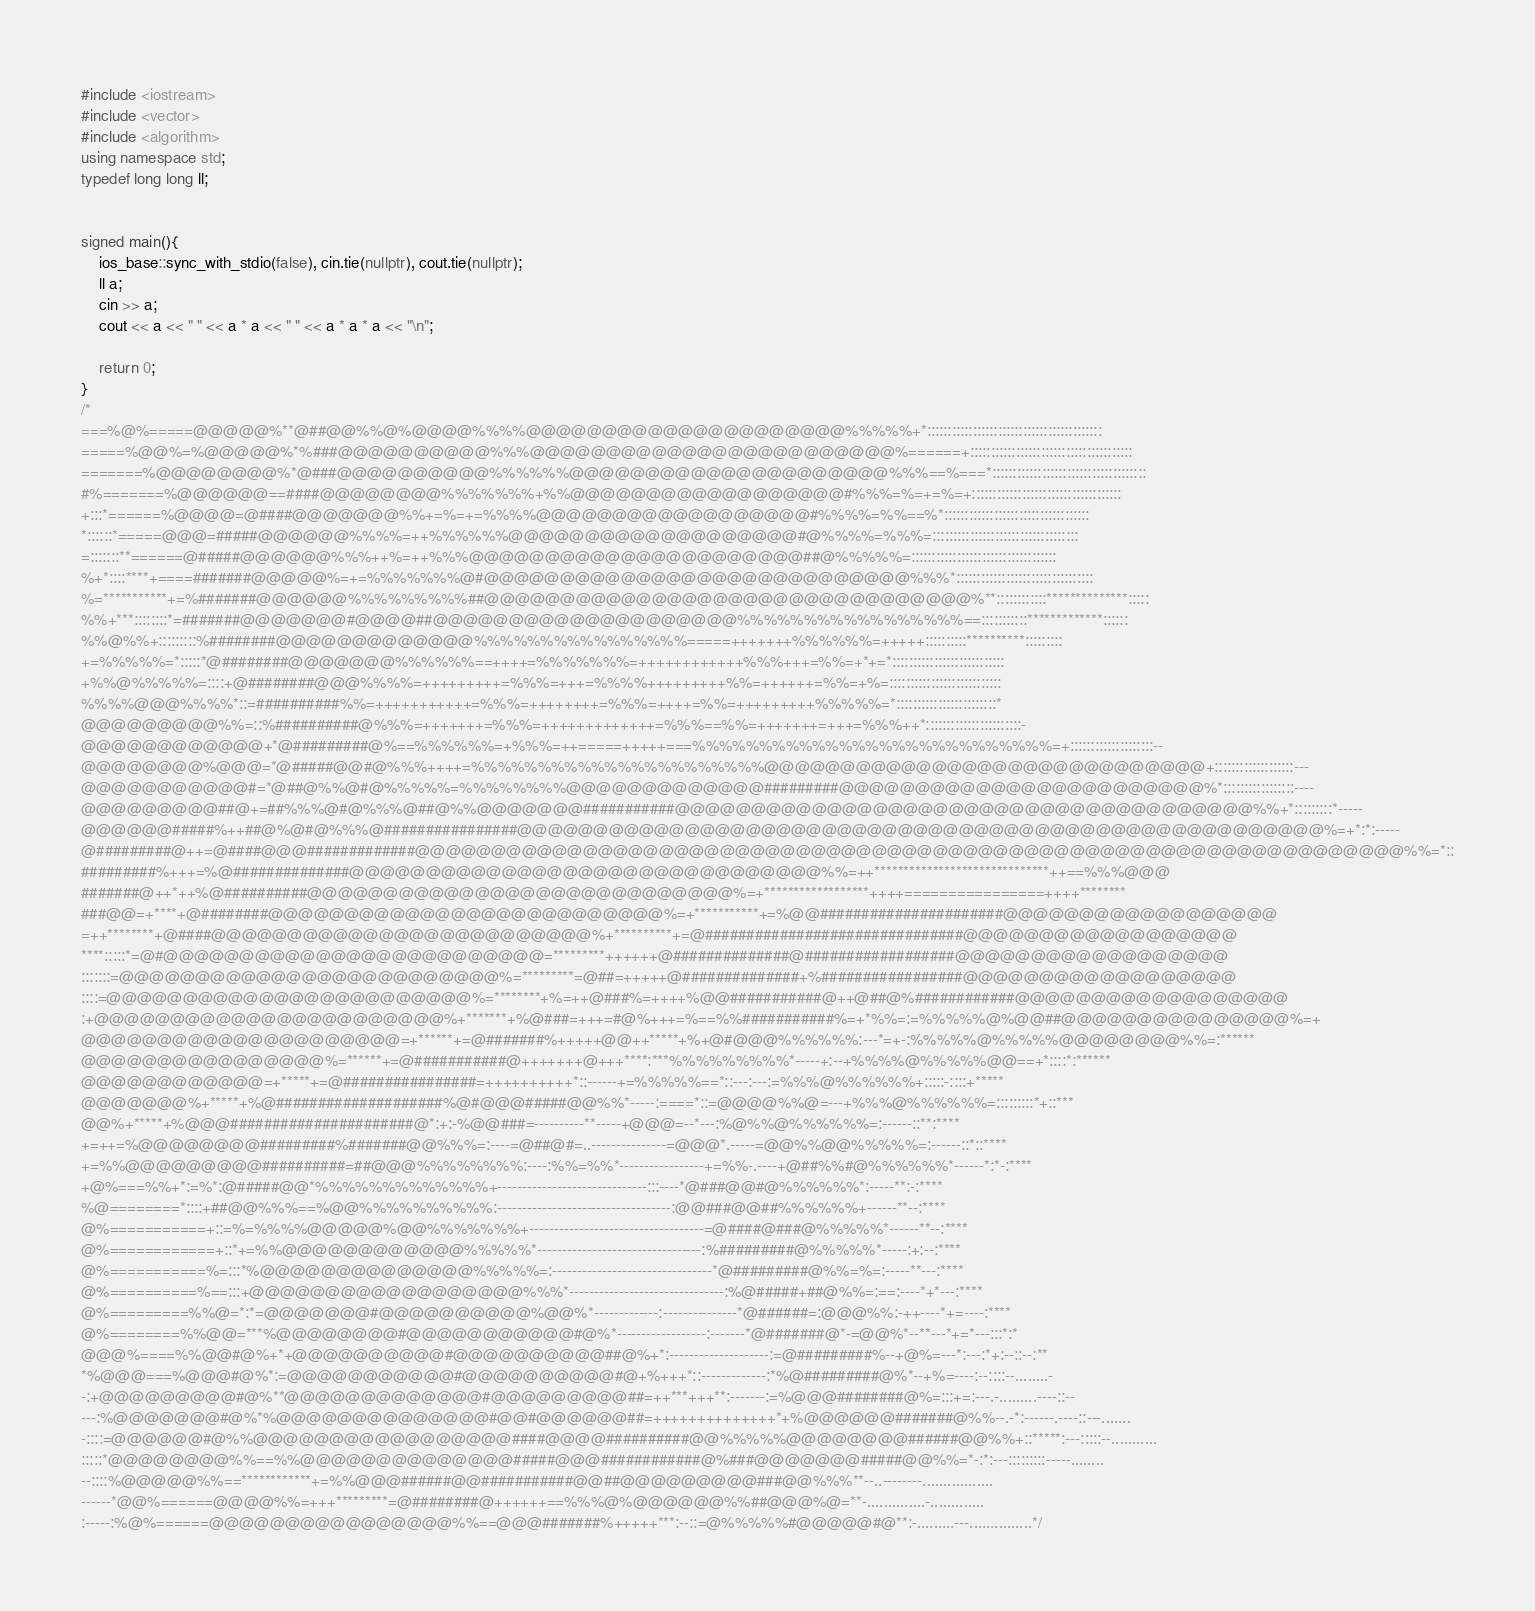<code> <loc_0><loc_0><loc_500><loc_500><_C++_>#include <iostream>
#include <vector>
#include <algorithm>
using namespace std;
typedef long long ll;


signed main(){
    ios_base::sync_with_stdio(false), cin.tie(nullptr), cout.tie(nullptr);
    ll a;
    cin >> a;
    cout << a << " " << a * a << " " << a * a * a << "\n";

    return 0;
}
/*
===%@%=====@@@@@%**@##@@%%@%@@@@%%%%@@@@@@@@@@@@@@@@@@@@@%%%%%+*::::::::::::::::::::::::::::::::::::::::::
=====%@@%=%@@@@@%*%###@@@@@@@@@@%%%@@@@@@@@@@@@@@@@@@@@@@@@%======+:::::::::::::::::::::::::::::::::::::::
=======%@@@@@@@@%*@###@@@@@@@@@@%%%%%%@@@@@@@@@@@@@@@@@@@@@%%%==%===*:::::::::::::::::::::::::::::::::::::
#%=======%@@@@@@==####@@@@@@@@%%%%%%%+%%@@@@@@@@@@@@@@@@@@#%%%=%=+=%=+::::::::::::::::::::::::::::::::::::
+:::*======%@@@@=@####@@@@@@@%%+=%=+=%%%%@@@@@@@@@@@@@@@@@@#%%%%=%%==%*:::::::::::::::::::::::::::::::::::
*::::::*=====@@@=#####@@@@@@%%%%=++%%%%%%@@@@@@@@@@@@@@@@@@@#@%%%%=%%%=:::::::::::::::::::::::::::::::::::
=:::::::**======@#####@@@@@@%%%++%=++%%%@@@@@@@@@@@@@@@@@@@@@@##@%%%%%=:::::::::::::::::::::::::::::::::::
%+*::::****+====#######@@@@@%=+=%%%%%%%@#@@@@@@@@@@@@@@@@@@@@@@@@@@@@%%%*:::::::::::::::::::::::::::::::::
%=***********+=%#######@@@@@@%%%%%%%%%##@@@@@@@@@@@@@@@@@@@@@@@@@@@@@@@@%**::::::::::::**************:::::
%%+***::::::::*=#######@@@@@@@#@@@@##@@@@@@@@@@@@@@@@@@@@%%%%%%%%%%%%%%%%%==:::::::::::*************::::::
%%@%%+:::::::::%########@@@@@@@@@@@@@%%%%%%%%%%%%%%%%=====+++++++%%%%%%=+++++::::::::::**********:::::::::
+=%%%%%=*:::::*@########@@@@@@@%%%%%%==++++=%%%%%%%=++++++++++++%%%+++=%%=+*+=*:::::::::::::::::::::::::::
+%%@%%%%%=::::+@########@@@%%%%=+++++++++=%%%=+++=%%%%+++++++++%%=++++++=%%=+%=:::::::::::::::::::::::::::
%%%%@@@%%%%*::=##########%%=+++++++++++=%%%=++++++++=%%%=++++=%%=+++++++++%%%%%=*::::::::::::::::::::::::*
@@@@@@@@@%%=::%##########@%%%=+++++++=%%%=+++++++++++++=%%%==%%=+++++++=+++=%%%++*:::::::::::::::::::::::-
@@@@@@@@@@@@+*@#########@%==%%%%%%=+%%%=++=====+++++===%%%%%%%%%%%%%%%%%%%%%%%%%%%=+::::::::::::::::::::--
@@@@@@@@%@@@=*@#####@@#@%%%++++=%%%%%%%%%%%%%%%%%%%%%%@@@@@@@@@@@@@@@@@@@@@@@@@@@@@+:::::::::::::::::::---
@@@@@@@@@@@#=*@##@%%@#@%%%%%=%%%%%%%%@@@@@@@@@@@@@#########@@@@@@@@@@@@@@@@@@@@@@@@%*:::::::::::::::::----
@@@@@@@@@##@+=##%%%@#@%%%@##@%%@@@@@@@###########@@@@@@@@@@@@@@@@@@@@@@@@@@@@@@@@@@@@@@%%+*:::::::::*-----
@@@@@@#####%++##@%@#@%%%@################@@@@@@@@@@@@@@@@@@@@@@@@@@@@@@@@@@@@@@@@@@@@@@@@@@@@@%=+*:*:-----
@#########@++=@####@@@#############@@@@@@@@@@@@@@@@@@@@@@@@@@@@@@@@@@@@@@@@@@@@@@@@@@@@@@@@@@@@@@@@@%%=*::
#########%+++=%@##############@@@@@@@@@@@@@@@@@@@@@@@@@@@@@@@%%=++******************************++==%%%@@@
#######@++*++%@##########@@@@@@@@@@@@@@@@@@@@@@@@@@@@%=+******************++++================++++********
###@@=+****+@########@@@@@@@@@@@@@@@@@@@@@@@@@@%=+***********+=%@@######################@@@@@@@@@@@@@@@@@@
=++********+@####@@@@@@@@@@@@@@@@@@@@@@@@@%+**********+=@###############################@@@@@@@@@@@@@@@@@@
****:::::*=@#@@@@@@@@@@@@@@@@@@@@@@@@@=*********++++++@##############@##################@@@@@@@@@@@@@@@@@@
:::::::=@@@@@@@@@@@@@@@@@@@@@@@@@%=*********=@##=+++++@##############+%#################@@@@@@@@@@@@@@@@@@
::::=@@@@@@@@@@@@@@@@@@@@@@@@%=********+%=++@###%=++++%@@###########@++@##@%############@@@@@@@@@@@@@@@@@@
:+@@@@@@@@@@@@@@@@@@@@@@@%+*******+%@###=+++=#@%+++=%==%%###########%=+*%%=:=%%%%%@%@@##@@@@@@@@@@@@@@@%=+
@@@@@@@@@@@@@@@@@@@@@=+******+=@#######%+++++@@++*****+%+@#@@@%%%%%%:---*=+-:%%%%%@%%%%%@@@@@@@@%%=:******
@@@@@@@@@@@@@@@@%=******+=@###########@+++++++@+++****:***%%%%%%%%%*-----+:--+%%%%@%%%%%@@==+*::::*:******
@@@@@@@@@@@@=+*****+=@################=++++++++++*::------+=%%%%%==*::---:---:=%%%@%%%%%%+:::::-::::+*****
@@@@@@@%+*****+%@####################%@#@@@#####@@%%*-----:====*::=@@@@%%@=---+%%%@%%%%%%=:::::::::*+::***
@@%+*****+%@@@######################@*:+:-%@@###=----------**-----+@@@=--*---:%@%%@%%%%%%=:------::**:****
+=++=%@@@@@@@@#########%#######@@%%%=:----=@##@#=..---------------=@@@*.-----=@@%%@@%%%%%=:------::*::****
+=%%@@@@@@@@@##########=##@@@%%%%%%%%:----:%%=%%*-----------------+=%%-.----+@##%%#@%%%%%%*------*:*-:****
+@%===%%+*:=%*:@#####@@*%%%%%%%%%%%%%+------------------------------:::----*@###@@#@%%%%%%*:-----**:-:****
%@========*::::+##@@%%%==%@@%%%%%%%%%%:-----------------------------------:@@###@@##%%%%%%+------**--:****
@%===========+::=%=%%%%@@@@@%@@%%%%%%%+-----------------------------------=@####@###@%%%%%*------**--:****
@%============+::*+=%%@@@@@@@@@@@@%%%%%*---------------------------------:%#########@%%%%%*-----:+:--:****
@%===========%=:::*%@@@@@@@@@@@@@@%%%%%=:--------------------------------*@#########@%%=%=:-----**---:****
@%==========%==:::+@@@@@@@@@@@@@@@@@@%%%*-------------------------------:%@#####+##@%%=:==:----*+*---:****
@%=========%%@=*:*=@@@@@@@#@@@@@@@@@@%@@%*-------------:---------------*@######=:@@@%%:-++----*+=----:****
@%========%%@@=***%@@@@@@@@#@@@@@@@@@@@#@%*------------------:-------*@#######@*-=@@%*--**---*+=*---:::*:*
@@@%====%%@@#@%+*+@@@@@@@@@@#@@@@@@@@@@##@%+*:--------------------:=@#########%--+@%=---*:---:*+:--::--:**
*%@@@===%@@@#@%*:=@@@@@@@@@@@#@@@@@@@@@@#@+%+++*::-------------:*%@#########@%*--+%=----:--::::--........-
-:+@@@@@@@@@#@%**@@@@@@@@@@@@@#@@@@@@@@@##=++***+++**:-------:=%@@@########@%=:::+=:---.-.........----::--
---:%@@@@@@@#@%*%@@@@@@@@@@@@@@#@@#@@@@@@##=++++++++++++++*+%@@@@@@#######@%%--.-*:------.----::---.......
-::::=@@@@@@#@%%@@@@@@@@@@@@@@@@@####@@@@##########@@%%%%%@@@@@@@@######@@%%+::*****:---:::::--...........
:::::*@@@@@@@@%%==%%@@@@@@@@@@@@@@#####@@@############@%###@@@@@@@#####@@%%=*-:*:---:::::::::-----........
--::::%@@@@@%%==************+=%%@@@######@@###########@@##@@@@@@@@@###@@%%%**--..--------.................
------*@@%======@@@@%%=+++*********=@########@++++++==%%%@%@@@@@@%%##@@@%@=**-..............-.............
:-----:%@%======@@@@@@@@@@@@@@@@%%==@@@#######%+++++***:--::=@%%%%%#@@@@@#@**:-.........---...............*/</code> 